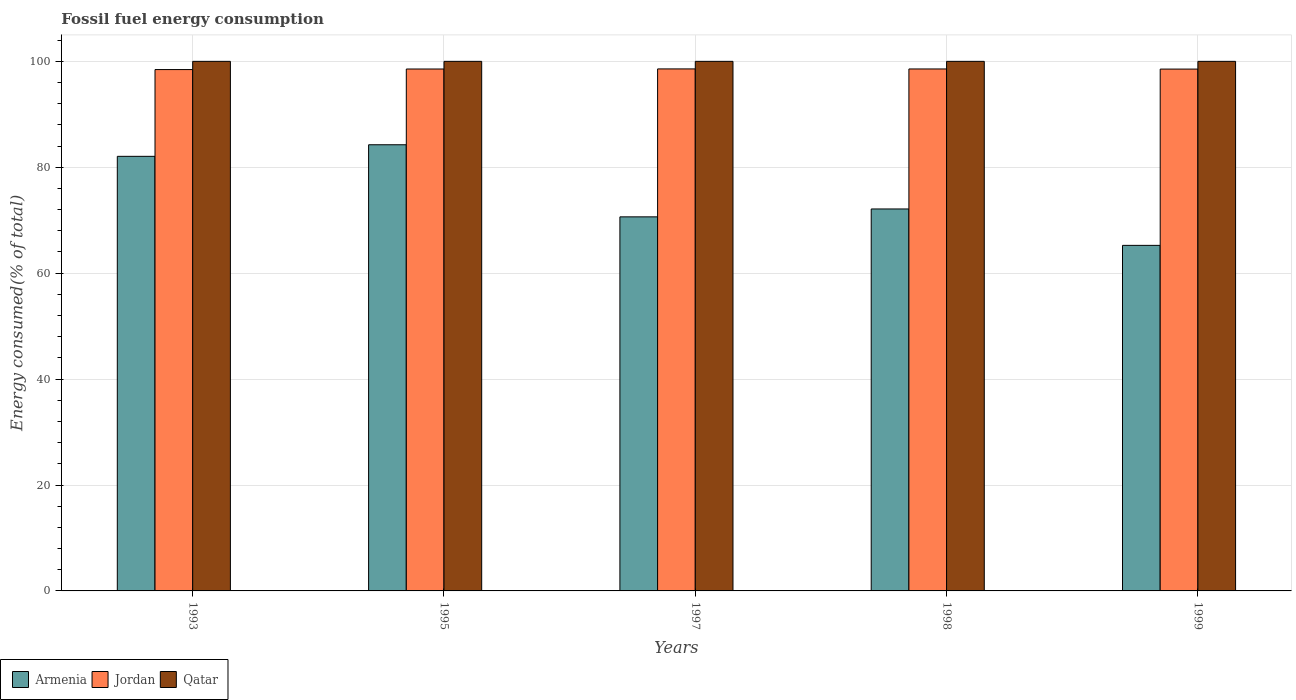How many different coloured bars are there?
Provide a succinct answer. 3. How many groups of bars are there?
Your answer should be compact. 5. Are the number of bars on each tick of the X-axis equal?
Give a very brief answer. Yes. How many bars are there on the 5th tick from the left?
Ensure brevity in your answer.  3. What is the label of the 3rd group of bars from the left?
Offer a very short reply. 1997. What is the percentage of energy consumed in Qatar in 1999?
Offer a very short reply. 100. Across all years, what is the maximum percentage of energy consumed in Qatar?
Your answer should be compact. 100. Across all years, what is the minimum percentage of energy consumed in Armenia?
Your answer should be compact. 65.25. In which year was the percentage of energy consumed in Qatar maximum?
Ensure brevity in your answer.  1995. In which year was the percentage of energy consumed in Armenia minimum?
Offer a terse response. 1999. What is the total percentage of energy consumed in Jordan in the graph?
Make the answer very short. 492.68. What is the difference between the percentage of energy consumed in Armenia in 1997 and that in 1999?
Keep it short and to the point. 5.38. What is the difference between the percentage of energy consumed in Armenia in 1998 and the percentage of energy consumed in Jordan in 1997?
Your answer should be compact. -26.45. What is the average percentage of energy consumed in Jordan per year?
Your answer should be compact. 98.54. In the year 1999, what is the difference between the percentage of energy consumed in Jordan and percentage of energy consumed in Qatar?
Provide a succinct answer. -1.46. What is the ratio of the percentage of energy consumed in Qatar in 1998 to that in 1999?
Give a very brief answer. 1. Is the percentage of energy consumed in Armenia in 1997 less than that in 1999?
Your answer should be very brief. No. Is the difference between the percentage of energy consumed in Jordan in 1993 and 1997 greater than the difference between the percentage of energy consumed in Qatar in 1993 and 1997?
Give a very brief answer. No. What is the difference between the highest and the second highest percentage of energy consumed in Jordan?
Your answer should be compact. 0.01. What is the difference between the highest and the lowest percentage of energy consumed in Qatar?
Offer a terse response. 1.276248769954691e-5. What does the 3rd bar from the left in 1997 represents?
Provide a succinct answer. Qatar. What does the 2nd bar from the right in 1999 represents?
Provide a succinct answer. Jordan. Is it the case that in every year, the sum of the percentage of energy consumed in Qatar and percentage of energy consumed in Jordan is greater than the percentage of energy consumed in Armenia?
Your response must be concise. Yes. How many years are there in the graph?
Provide a short and direct response. 5. Are the values on the major ticks of Y-axis written in scientific E-notation?
Provide a succinct answer. No. Does the graph contain grids?
Make the answer very short. Yes. How many legend labels are there?
Make the answer very short. 3. How are the legend labels stacked?
Provide a short and direct response. Horizontal. What is the title of the graph?
Your response must be concise. Fossil fuel energy consumption. Does "Libya" appear as one of the legend labels in the graph?
Make the answer very short. No. What is the label or title of the Y-axis?
Your answer should be very brief. Energy consumed(% of total). What is the Energy consumed(% of total) in Armenia in 1993?
Keep it short and to the point. 82.06. What is the Energy consumed(% of total) in Jordan in 1993?
Offer a very short reply. 98.45. What is the Energy consumed(% of total) of Qatar in 1993?
Give a very brief answer. 100. What is the Energy consumed(% of total) in Armenia in 1995?
Offer a very short reply. 84.25. What is the Energy consumed(% of total) of Jordan in 1995?
Offer a very short reply. 98.55. What is the Energy consumed(% of total) in Armenia in 1997?
Offer a very short reply. 70.64. What is the Energy consumed(% of total) in Jordan in 1997?
Make the answer very short. 98.57. What is the Energy consumed(% of total) of Qatar in 1997?
Offer a terse response. 100. What is the Energy consumed(% of total) in Armenia in 1998?
Provide a short and direct response. 72.13. What is the Energy consumed(% of total) in Jordan in 1998?
Offer a very short reply. 98.56. What is the Energy consumed(% of total) of Qatar in 1998?
Provide a short and direct response. 100. What is the Energy consumed(% of total) of Armenia in 1999?
Provide a short and direct response. 65.25. What is the Energy consumed(% of total) in Jordan in 1999?
Provide a succinct answer. 98.54. What is the Energy consumed(% of total) of Qatar in 1999?
Your response must be concise. 100. Across all years, what is the maximum Energy consumed(% of total) in Armenia?
Your answer should be very brief. 84.25. Across all years, what is the maximum Energy consumed(% of total) of Jordan?
Make the answer very short. 98.57. Across all years, what is the minimum Energy consumed(% of total) of Armenia?
Your answer should be compact. 65.25. Across all years, what is the minimum Energy consumed(% of total) of Jordan?
Offer a terse response. 98.45. Across all years, what is the minimum Energy consumed(% of total) in Qatar?
Provide a short and direct response. 100. What is the total Energy consumed(% of total) of Armenia in the graph?
Offer a terse response. 374.33. What is the total Energy consumed(% of total) in Jordan in the graph?
Your answer should be compact. 492.68. What is the difference between the Energy consumed(% of total) of Armenia in 1993 and that in 1995?
Your answer should be compact. -2.19. What is the difference between the Energy consumed(% of total) in Jordan in 1993 and that in 1995?
Provide a succinct answer. -0.1. What is the difference between the Energy consumed(% of total) of Qatar in 1993 and that in 1995?
Give a very brief answer. -0. What is the difference between the Energy consumed(% of total) of Armenia in 1993 and that in 1997?
Offer a very short reply. 11.43. What is the difference between the Energy consumed(% of total) in Jordan in 1993 and that in 1997?
Offer a very short reply. -0.12. What is the difference between the Energy consumed(% of total) in Armenia in 1993 and that in 1998?
Your answer should be very brief. 9.94. What is the difference between the Energy consumed(% of total) in Jordan in 1993 and that in 1998?
Offer a terse response. -0.11. What is the difference between the Energy consumed(% of total) in Armenia in 1993 and that in 1999?
Offer a very short reply. 16.81. What is the difference between the Energy consumed(% of total) of Jordan in 1993 and that in 1999?
Keep it short and to the point. -0.09. What is the difference between the Energy consumed(% of total) of Qatar in 1993 and that in 1999?
Your answer should be compact. -0. What is the difference between the Energy consumed(% of total) in Armenia in 1995 and that in 1997?
Your answer should be very brief. 13.62. What is the difference between the Energy consumed(% of total) of Jordan in 1995 and that in 1997?
Provide a succinct answer. -0.02. What is the difference between the Energy consumed(% of total) of Armenia in 1995 and that in 1998?
Your response must be concise. 12.12. What is the difference between the Energy consumed(% of total) in Jordan in 1995 and that in 1998?
Offer a terse response. -0.01. What is the difference between the Energy consumed(% of total) in Armenia in 1995 and that in 1999?
Offer a terse response. 19. What is the difference between the Energy consumed(% of total) in Jordan in 1995 and that in 1999?
Keep it short and to the point. 0.01. What is the difference between the Energy consumed(% of total) of Qatar in 1995 and that in 1999?
Provide a succinct answer. 0. What is the difference between the Energy consumed(% of total) in Armenia in 1997 and that in 1998?
Your response must be concise. -1.49. What is the difference between the Energy consumed(% of total) of Jordan in 1997 and that in 1998?
Ensure brevity in your answer.  0.01. What is the difference between the Energy consumed(% of total) of Armenia in 1997 and that in 1999?
Your answer should be very brief. 5.38. What is the difference between the Energy consumed(% of total) in Jordan in 1997 and that in 1999?
Your answer should be compact. 0.03. What is the difference between the Energy consumed(% of total) of Armenia in 1998 and that in 1999?
Provide a short and direct response. 6.87. What is the difference between the Energy consumed(% of total) in Jordan in 1998 and that in 1999?
Your response must be concise. 0.02. What is the difference between the Energy consumed(% of total) of Armenia in 1993 and the Energy consumed(% of total) of Jordan in 1995?
Ensure brevity in your answer.  -16.49. What is the difference between the Energy consumed(% of total) of Armenia in 1993 and the Energy consumed(% of total) of Qatar in 1995?
Provide a short and direct response. -17.94. What is the difference between the Energy consumed(% of total) of Jordan in 1993 and the Energy consumed(% of total) of Qatar in 1995?
Ensure brevity in your answer.  -1.55. What is the difference between the Energy consumed(% of total) in Armenia in 1993 and the Energy consumed(% of total) in Jordan in 1997?
Provide a succinct answer. -16.51. What is the difference between the Energy consumed(% of total) in Armenia in 1993 and the Energy consumed(% of total) in Qatar in 1997?
Provide a short and direct response. -17.94. What is the difference between the Energy consumed(% of total) of Jordan in 1993 and the Energy consumed(% of total) of Qatar in 1997?
Your answer should be compact. -1.55. What is the difference between the Energy consumed(% of total) in Armenia in 1993 and the Energy consumed(% of total) in Jordan in 1998?
Offer a very short reply. -16.5. What is the difference between the Energy consumed(% of total) in Armenia in 1993 and the Energy consumed(% of total) in Qatar in 1998?
Your response must be concise. -17.94. What is the difference between the Energy consumed(% of total) of Jordan in 1993 and the Energy consumed(% of total) of Qatar in 1998?
Offer a terse response. -1.55. What is the difference between the Energy consumed(% of total) of Armenia in 1993 and the Energy consumed(% of total) of Jordan in 1999?
Provide a succinct answer. -16.48. What is the difference between the Energy consumed(% of total) of Armenia in 1993 and the Energy consumed(% of total) of Qatar in 1999?
Offer a terse response. -17.94. What is the difference between the Energy consumed(% of total) in Jordan in 1993 and the Energy consumed(% of total) in Qatar in 1999?
Give a very brief answer. -1.55. What is the difference between the Energy consumed(% of total) in Armenia in 1995 and the Energy consumed(% of total) in Jordan in 1997?
Make the answer very short. -14.32. What is the difference between the Energy consumed(% of total) of Armenia in 1995 and the Energy consumed(% of total) of Qatar in 1997?
Give a very brief answer. -15.75. What is the difference between the Energy consumed(% of total) of Jordan in 1995 and the Energy consumed(% of total) of Qatar in 1997?
Give a very brief answer. -1.45. What is the difference between the Energy consumed(% of total) in Armenia in 1995 and the Energy consumed(% of total) in Jordan in 1998?
Give a very brief answer. -14.31. What is the difference between the Energy consumed(% of total) in Armenia in 1995 and the Energy consumed(% of total) in Qatar in 1998?
Offer a very short reply. -15.75. What is the difference between the Energy consumed(% of total) in Jordan in 1995 and the Energy consumed(% of total) in Qatar in 1998?
Provide a succinct answer. -1.45. What is the difference between the Energy consumed(% of total) of Armenia in 1995 and the Energy consumed(% of total) of Jordan in 1999?
Keep it short and to the point. -14.29. What is the difference between the Energy consumed(% of total) of Armenia in 1995 and the Energy consumed(% of total) of Qatar in 1999?
Provide a short and direct response. -15.75. What is the difference between the Energy consumed(% of total) of Jordan in 1995 and the Energy consumed(% of total) of Qatar in 1999?
Ensure brevity in your answer.  -1.45. What is the difference between the Energy consumed(% of total) in Armenia in 1997 and the Energy consumed(% of total) in Jordan in 1998?
Keep it short and to the point. -27.93. What is the difference between the Energy consumed(% of total) in Armenia in 1997 and the Energy consumed(% of total) in Qatar in 1998?
Offer a terse response. -29.36. What is the difference between the Energy consumed(% of total) in Jordan in 1997 and the Energy consumed(% of total) in Qatar in 1998?
Make the answer very short. -1.43. What is the difference between the Energy consumed(% of total) in Armenia in 1997 and the Energy consumed(% of total) in Jordan in 1999?
Your answer should be very brief. -27.9. What is the difference between the Energy consumed(% of total) in Armenia in 1997 and the Energy consumed(% of total) in Qatar in 1999?
Ensure brevity in your answer.  -29.36. What is the difference between the Energy consumed(% of total) of Jordan in 1997 and the Energy consumed(% of total) of Qatar in 1999?
Your answer should be very brief. -1.43. What is the difference between the Energy consumed(% of total) of Armenia in 1998 and the Energy consumed(% of total) of Jordan in 1999?
Your answer should be compact. -26.41. What is the difference between the Energy consumed(% of total) in Armenia in 1998 and the Energy consumed(% of total) in Qatar in 1999?
Your answer should be very brief. -27.87. What is the difference between the Energy consumed(% of total) of Jordan in 1998 and the Energy consumed(% of total) of Qatar in 1999?
Offer a terse response. -1.44. What is the average Energy consumed(% of total) in Armenia per year?
Offer a terse response. 74.87. What is the average Energy consumed(% of total) of Jordan per year?
Make the answer very short. 98.54. In the year 1993, what is the difference between the Energy consumed(% of total) in Armenia and Energy consumed(% of total) in Jordan?
Make the answer very short. -16.39. In the year 1993, what is the difference between the Energy consumed(% of total) of Armenia and Energy consumed(% of total) of Qatar?
Your response must be concise. -17.94. In the year 1993, what is the difference between the Energy consumed(% of total) in Jordan and Energy consumed(% of total) in Qatar?
Keep it short and to the point. -1.55. In the year 1995, what is the difference between the Energy consumed(% of total) in Armenia and Energy consumed(% of total) in Jordan?
Provide a succinct answer. -14.3. In the year 1995, what is the difference between the Energy consumed(% of total) in Armenia and Energy consumed(% of total) in Qatar?
Provide a succinct answer. -15.75. In the year 1995, what is the difference between the Energy consumed(% of total) in Jordan and Energy consumed(% of total) in Qatar?
Make the answer very short. -1.45. In the year 1997, what is the difference between the Energy consumed(% of total) in Armenia and Energy consumed(% of total) in Jordan?
Offer a terse response. -27.94. In the year 1997, what is the difference between the Energy consumed(% of total) in Armenia and Energy consumed(% of total) in Qatar?
Offer a terse response. -29.36. In the year 1997, what is the difference between the Energy consumed(% of total) of Jordan and Energy consumed(% of total) of Qatar?
Ensure brevity in your answer.  -1.43. In the year 1998, what is the difference between the Energy consumed(% of total) in Armenia and Energy consumed(% of total) in Jordan?
Make the answer very short. -26.44. In the year 1998, what is the difference between the Energy consumed(% of total) in Armenia and Energy consumed(% of total) in Qatar?
Give a very brief answer. -27.87. In the year 1998, what is the difference between the Energy consumed(% of total) in Jordan and Energy consumed(% of total) in Qatar?
Keep it short and to the point. -1.44. In the year 1999, what is the difference between the Energy consumed(% of total) of Armenia and Energy consumed(% of total) of Jordan?
Ensure brevity in your answer.  -33.29. In the year 1999, what is the difference between the Energy consumed(% of total) of Armenia and Energy consumed(% of total) of Qatar?
Ensure brevity in your answer.  -34.75. In the year 1999, what is the difference between the Energy consumed(% of total) in Jordan and Energy consumed(% of total) in Qatar?
Make the answer very short. -1.46. What is the ratio of the Energy consumed(% of total) in Qatar in 1993 to that in 1995?
Ensure brevity in your answer.  1. What is the ratio of the Energy consumed(% of total) of Armenia in 1993 to that in 1997?
Make the answer very short. 1.16. What is the ratio of the Energy consumed(% of total) of Qatar in 1993 to that in 1997?
Offer a very short reply. 1. What is the ratio of the Energy consumed(% of total) in Armenia in 1993 to that in 1998?
Offer a terse response. 1.14. What is the ratio of the Energy consumed(% of total) of Jordan in 1993 to that in 1998?
Your answer should be very brief. 1. What is the ratio of the Energy consumed(% of total) of Qatar in 1993 to that in 1998?
Ensure brevity in your answer.  1. What is the ratio of the Energy consumed(% of total) of Armenia in 1993 to that in 1999?
Keep it short and to the point. 1.26. What is the ratio of the Energy consumed(% of total) in Jordan in 1993 to that in 1999?
Provide a succinct answer. 1. What is the ratio of the Energy consumed(% of total) of Qatar in 1993 to that in 1999?
Provide a short and direct response. 1. What is the ratio of the Energy consumed(% of total) of Armenia in 1995 to that in 1997?
Provide a succinct answer. 1.19. What is the ratio of the Energy consumed(% of total) in Qatar in 1995 to that in 1997?
Your answer should be compact. 1. What is the ratio of the Energy consumed(% of total) of Armenia in 1995 to that in 1998?
Ensure brevity in your answer.  1.17. What is the ratio of the Energy consumed(% of total) of Qatar in 1995 to that in 1998?
Offer a terse response. 1. What is the ratio of the Energy consumed(% of total) in Armenia in 1995 to that in 1999?
Give a very brief answer. 1.29. What is the ratio of the Energy consumed(% of total) of Jordan in 1995 to that in 1999?
Offer a very short reply. 1. What is the ratio of the Energy consumed(% of total) of Qatar in 1995 to that in 1999?
Make the answer very short. 1. What is the ratio of the Energy consumed(% of total) in Armenia in 1997 to that in 1998?
Your answer should be very brief. 0.98. What is the ratio of the Energy consumed(% of total) in Qatar in 1997 to that in 1998?
Offer a terse response. 1. What is the ratio of the Energy consumed(% of total) in Armenia in 1997 to that in 1999?
Ensure brevity in your answer.  1.08. What is the ratio of the Energy consumed(% of total) of Jordan in 1997 to that in 1999?
Make the answer very short. 1. What is the ratio of the Energy consumed(% of total) of Qatar in 1997 to that in 1999?
Provide a succinct answer. 1. What is the ratio of the Energy consumed(% of total) in Armenia in 1998 to that in 1999?
Make the answer very short. 1.11. What is the ratio of the Energy consumed(% of total) in Qatar in 1998 to that in 1999?
Your response must be concise. 1. What is the difference between the highest and the second highest Energy consumed(% of total) in Armenia?
Provide a succinct answer. 2.19. What is the difference between the highest and the second highest Energy consumed(% of total) in Jordan?
Provide a short and direct response. 0.01. What is the difference between the highest and the second highest Energy consumed(% of total) of Qatar?
Give a very brief answer. 0. What is the difference between the highest and the lowest Energy consumed(% of total) in Armenia?
Provide a succinct answer. 19. What is the difference between the highest and the lowest Energy consumed(% of total) of Jordan?
Your answer should be compact. 0.12. 